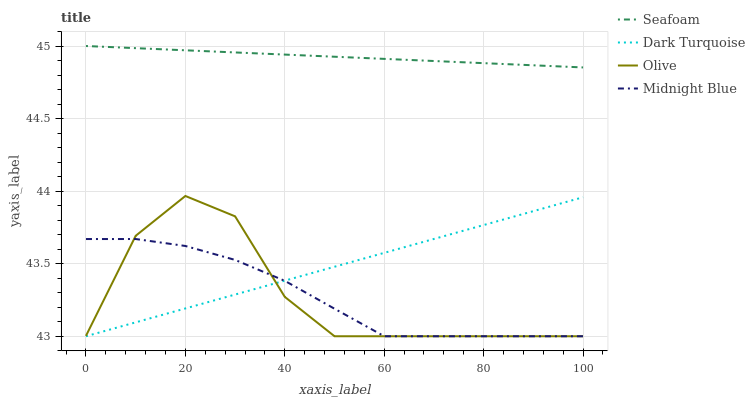Does Midnight Blue have the minimum area under the curve?
Answer yes or no. Yes. Does Seafoam have the maximum area under the curve?
Answer yes or no. Yes. Does Dark Turquoise have the minimum area under the curve?
Answer yes or no. No. Does Dark Turquoise have the maximum area under the curve?
Answer yes or no. No. Is Seafoam the smoothest?
Answer yes or no. Yes. Is Olive the roughest?
Answer yes or no. Yes. Is Dark Turquoise the smoothest?
Answer yes or no. No. Is Dark Turquoise the roughest?
Answer yes or no. No. Does Olive have the lowest value?
Answer yes or no. Yes. Does Seafoam have the lowest value?
Answer yes or no. No. Does Seafoam have the highest value?
Answer yes or no. Yes. Does Dark Turquoise have the highest value?
Answer yes or no. No. Is Dark Turquoise less than Seafoam?
Answer yes or no. Yes. Is Seafoam greater than Dark Turquoise?
Answer yes or no. Yes. Does Midnight Blue intersect Olive?
Answer yes or no. Yes. Is Midnight Blue less than Olive?
Answer yes or no. No. Is Midnight Blue greater than Olive?
Answer yes or no. No. Does Dark Turquoise intersect Seafoam?
Answer yes or no. No. 